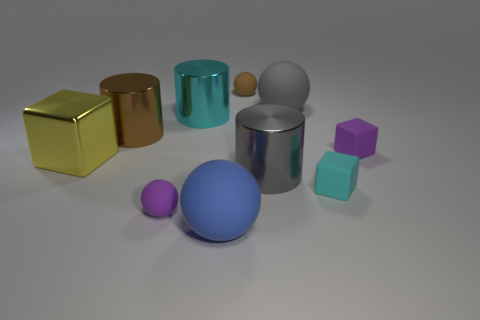Is the big gray rubber object the same shape as the cyan metal object?
Provide a succinct answer. No. What size is the purple matte object that is the same shape as the large blue matte thing?
Offer a very short reply. Small. There is a small purple rubber thing that is to the left of the large rubber thing that is on the left side of the gray cylinder; what shape is it?
Make the answer very short. Sphere. What is the size of the blue object?
Provide a short and direct response. Large. The large gray metal thing is what shape?
Provide a short and direct response. Cylinder. Does the small cyan thing have the same shape as the small purple rubber object right of the purple rubber sphere?
Offer a very short reply. Yes. There is a tiny purple rubber thing that is right of the tiny brown rubber ball; is it the same shape as the large cyan object?
Provide a short and direct response. No. What number of objects are on the right side of the big yellow thing and in front of the cyan shiny cylinder?
Ensure brevity in your answer.  6. What number of other things are there of the same size as the gray matte thing?
Keep it short and to the point. 5. Is the number of cylinders that are in front of the brown cylinder the same as the number of tiny brown balls?
Keep it short and to the point. Yes. 